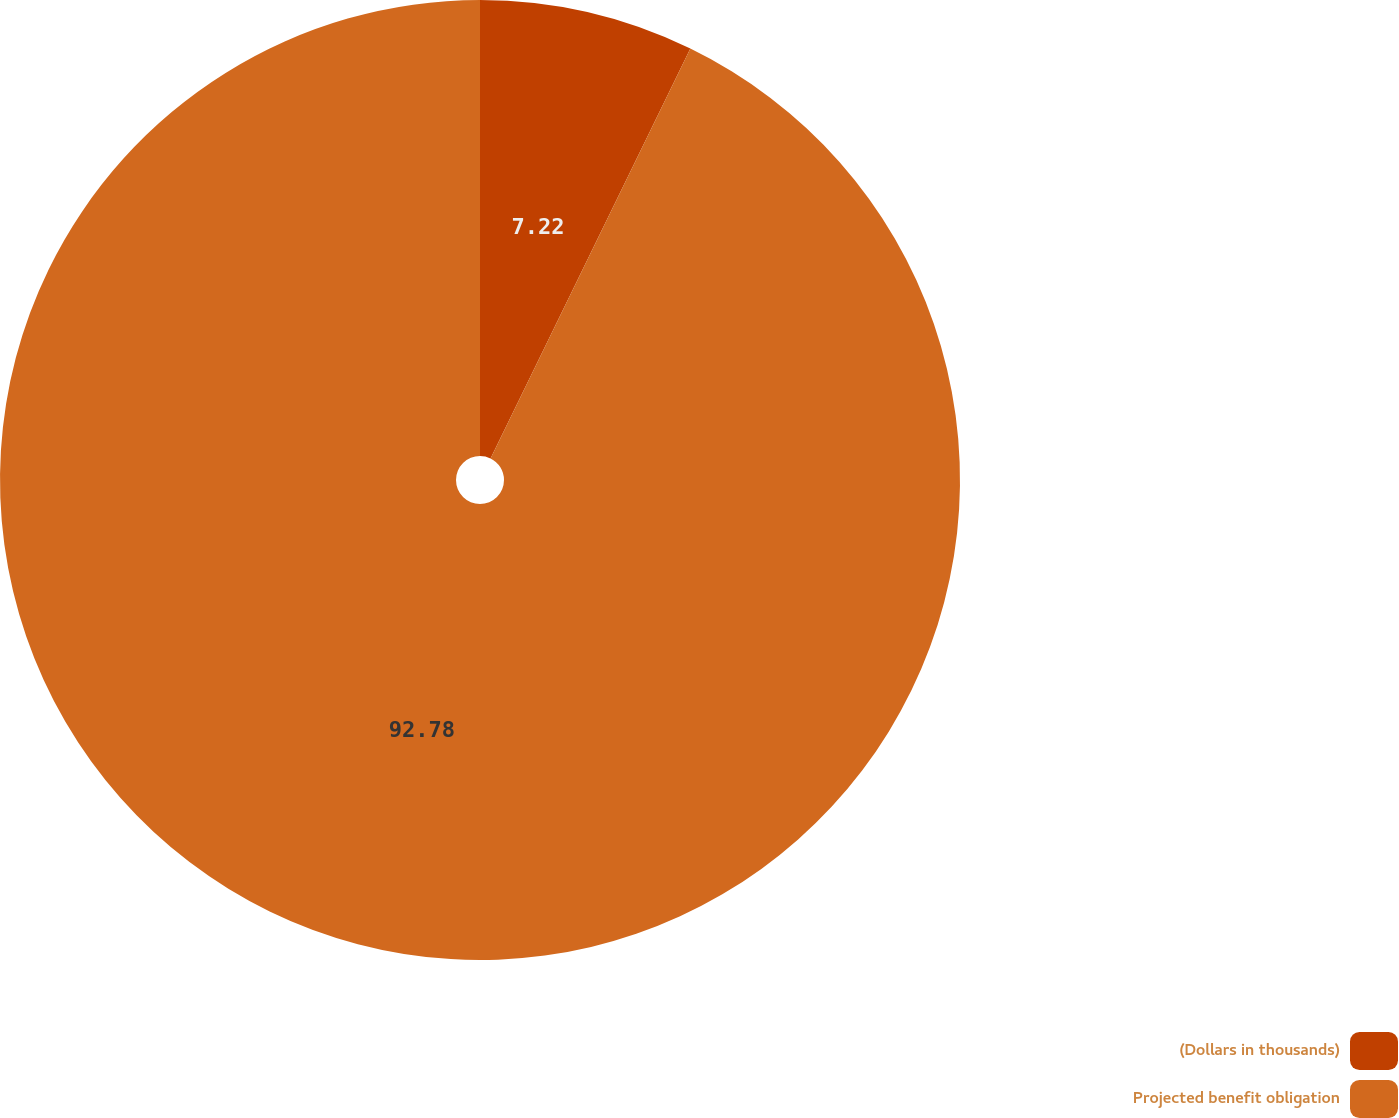Convert chart. <chart><loc_0><loc_0><loc_500><loc_500><pie_chart><fcel>(Dollars in thousands)<fcel>Projected benefit obligation<nl><fcel>7.22%<fcel>92.78%<nl></chart> 